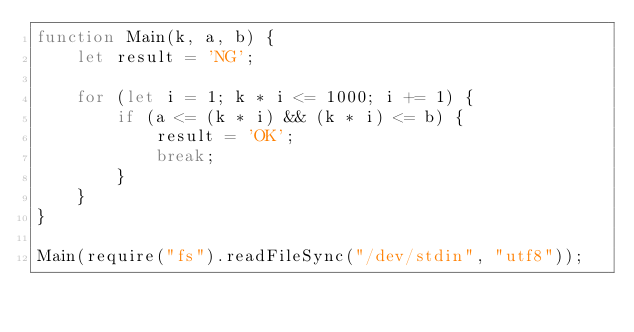<code> <loc_0><loc_0><loc_500><loc_500><_JavaScript_>function Main(k, a, b) {
    let result = 'NG';

    for (let i = 1; k * i <= 1000; i += 1) {
        if (a <= (k * i) && (k * i) <= b) {
            result = 'OK';
            break;
        }
    }  
}

Main(require("fs").readFileSync("/dev/stdin", "utf8"));</code> 